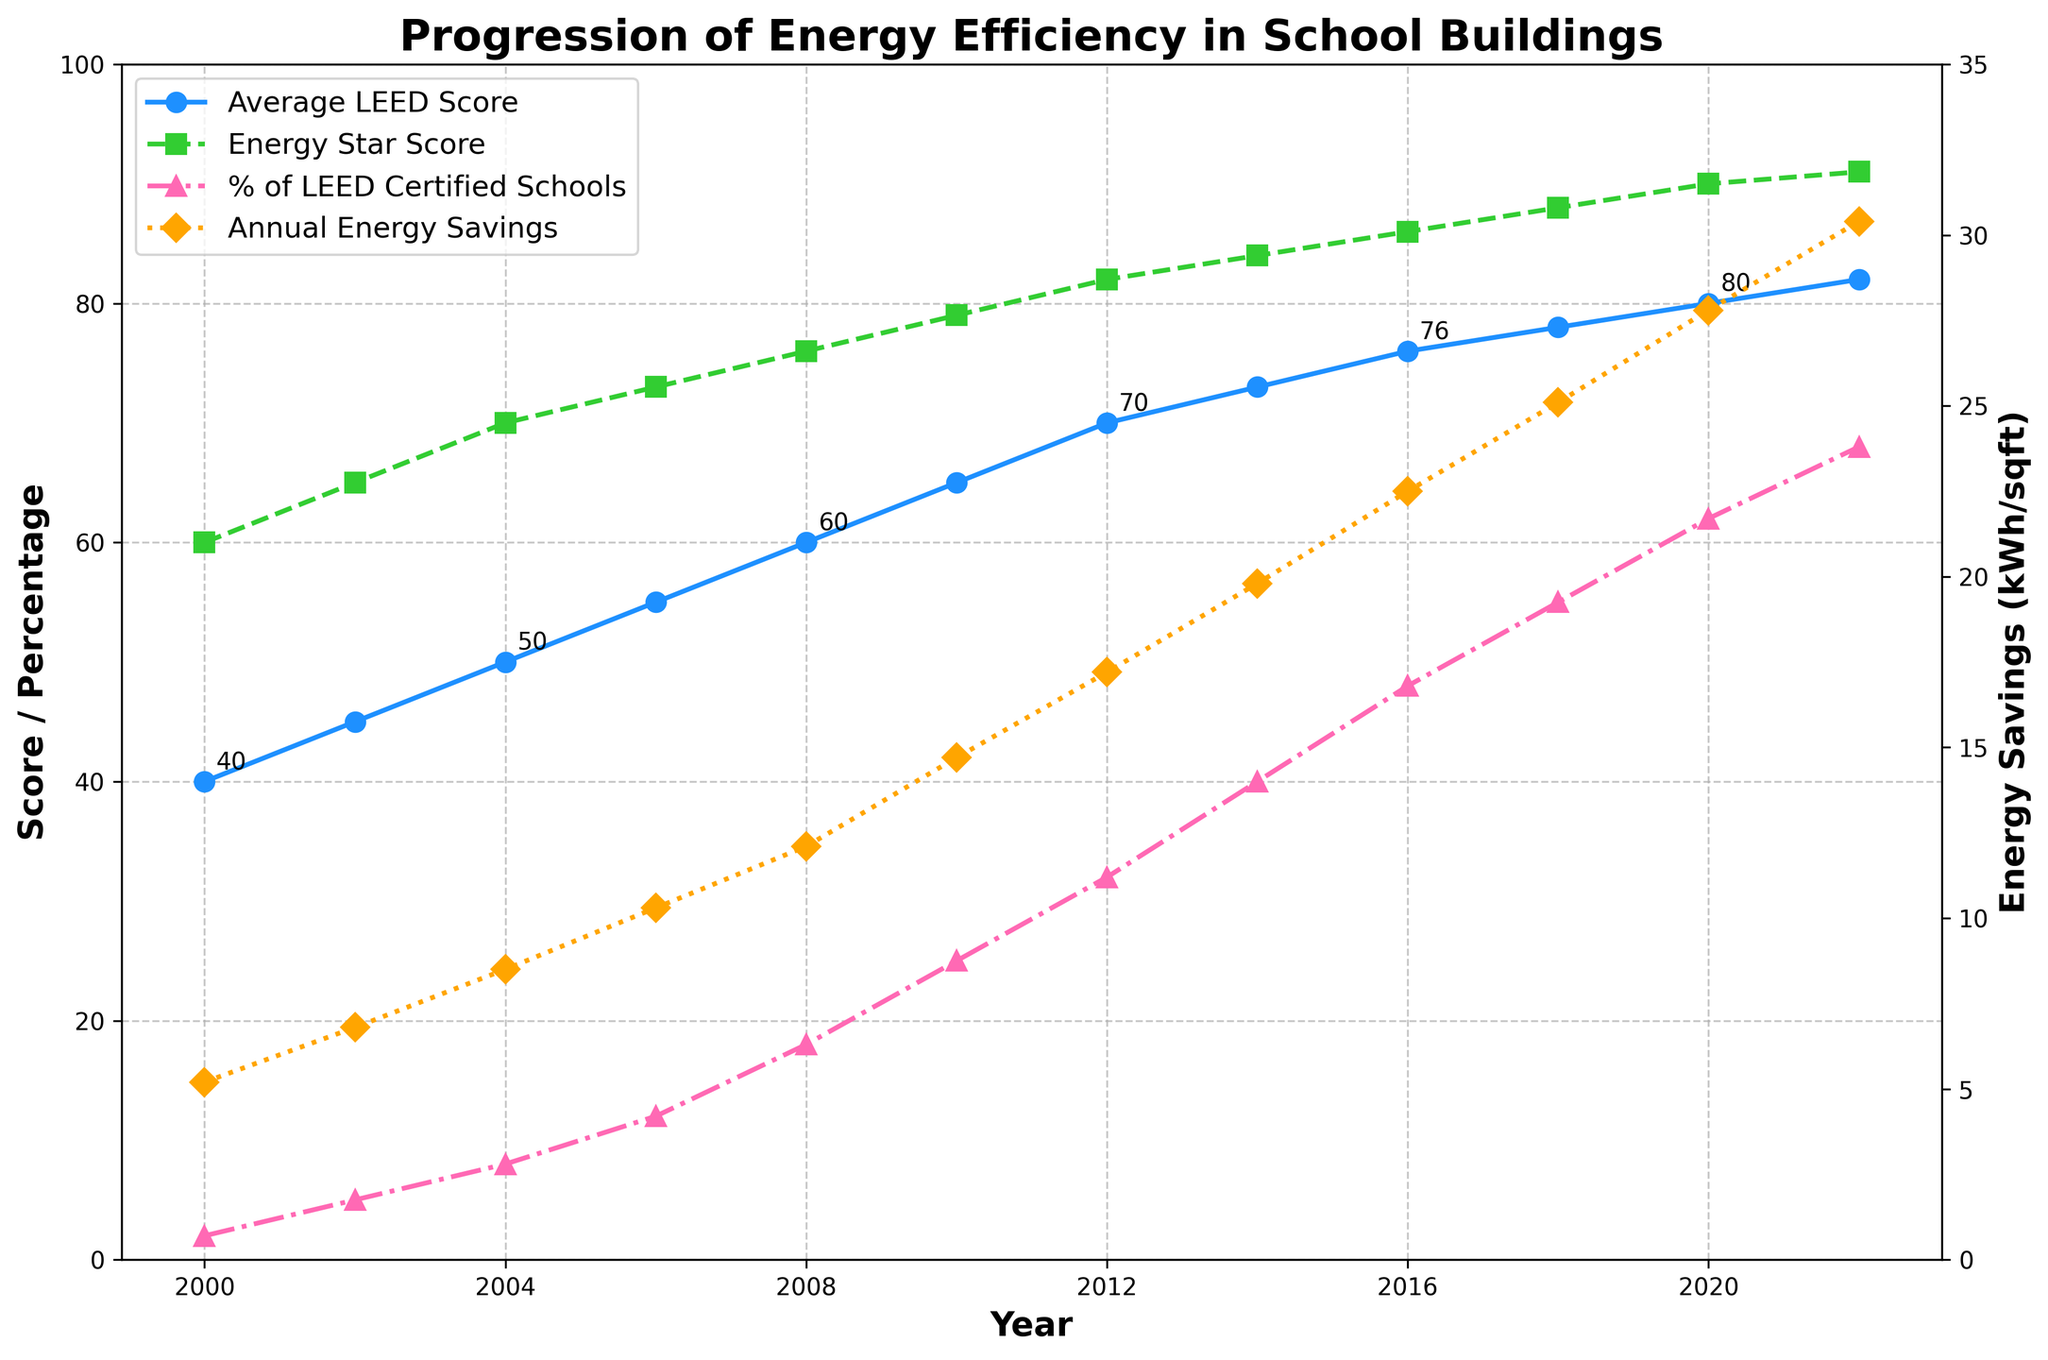What year did the Average LEED Score reach 70? By looking at the curve corresponding to the Average LEED Score, we see that it reaches 70 in 2012.
Answer: 2012 Which year shows the largest increase in Average LEED Score from the previous year? Calculate the difference in Average LEED Scores for consecutive years: (45-40), (50-45), (55-50), (60-55), (65-60), (70-65), (73-70), (76-73), (78-76), (80-78), (82-80). The largest increase is from 2008 to 2010, which is 5 points.
Answer: 2008 to 2010 Which metric reaches 90 first in the timeline, Energy Star Score or Average LEED Score? Locate the year when each metric reaches 90. The Energy Star Score reaches 90 in 2020, whereas the Average LEED Score does not reach 90 at all.
Answer: Energy Star Score How much is the Annual Energy Savings (kWh/sqft) in 2016? By looking at the orange dotted line marked with diamonds for 2016, we see the value of Annual Energy Savings is 22.5 kWh/sqft.
Answer: 22.5 kWh/sqft Which year sees the first significant increase in the percentage of LEED Certified Schools? By observing the pink dashed line with triangles, a significant increase can be seen between 2006 and 2008, where the percentage moves from 12% to 18%.
Answer: 2006 to 2008 What is the difference in Energy Star Scores between the years 2010 and 2022? Subtract the Energy Star Score of 2010 from that of 2022 (91 - 79).
Answer: 12 Between 2004 and 2014, did the Average LEED Score ever decrease? Examine the trend line for the Average LEED Score between 2004 and 2014; it consistently increases from 50 to 73.
Answer: No Which metric has the steepest upward trend over the years? Visual inspections show that the Annual Energy Savings (orange dotted line) has the steepest upward trend compared to the other metrics.
Answer: Annual Energy Savings How much has Annual Energy Savings (kWh/sqft) increased from 2000 to 2022? Subtract the initial value in 2000 (5.2) from the final value in 2022 (30.4): (30.4 - 5.2).
Answer: 25.2 kWh/sqft In what year do we see that the percentage of LEED Certified Schools first exceeds 50%? By following the trend line for the percentage of LEED Certified Schools, it first exceeds 50% in 2018.
Answer: 2018 